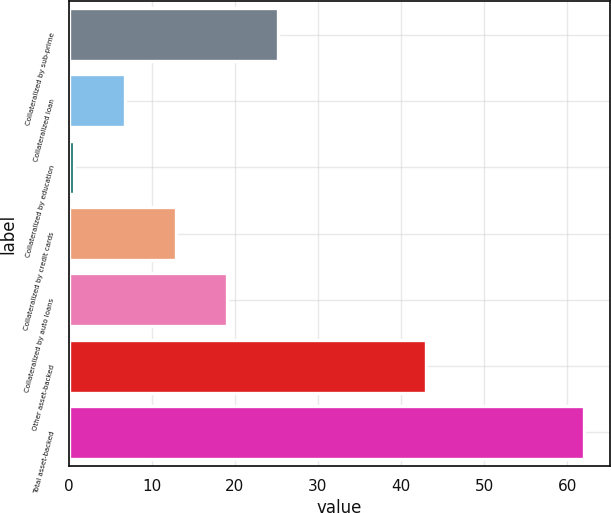<chart> <loc_0><loc_0><loc_500><loc_500><bar_chart><fcel>Collateralized by sub-prime<fcel>Collateralized loan<fcel>Collateralized by education<fcel>Collateralized by credit cards<fcel>Collateralized by auto loans<fcel>Other asset-backed<fcel>Total asset-backed<nl><fcel>25.2<fcel>6.78<fcel>0.64<fcel>12.92<fcel>19.06<fcel>43<fcel>62<nl></chart> 